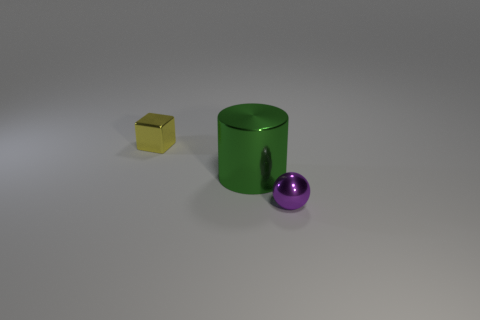The tiny thing that is the same material as the sphere is what shape?
Offer a terse response. Cube. Is there any other thing that has the same color as the tiny sphere?
Offer a very short reply. No. How many small metal spheres are there?
Your answer should be compact. 1. There is a metallic thing that is both on the left side of the small metal sphere and to the right of the yellow block; what is its shape?
Your answer should be very brief. Cylinder. What is the shape of the small thing that is to the right of the small metal thing that is behind the tiny object right of the small yellow thing?
Your response must be concise. Sphere. There is a thing that is behind the tiny purple shiny sphere and in front of the tiny yellow metallic cube; what material is it made of?
Make the answer very short. Metal. What number of green cylinders are the same size as the yellow metallic object?
Ensure brevity in your answer.  0. How many rubber things are yellow blocks or small balls?
Keep it short and to the point. 0. What is the material of the small yellow object?
Your answer should be very brief. Metal. There is a purple thing; what number of big shiny cylinders are left of it?
Provide a short and direct response. 1. 